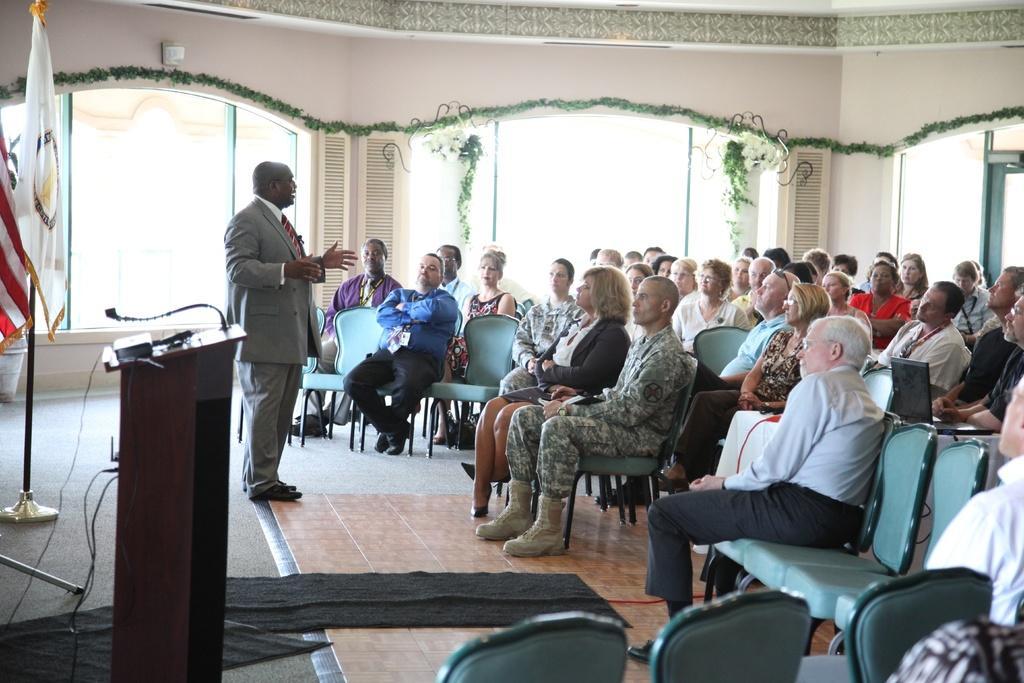Describe this image in one or two sentences. In this image, we can see people sitting and there is a man standing. In the background, there are flags and there is a mic stand and we can see some decor on the wall. 